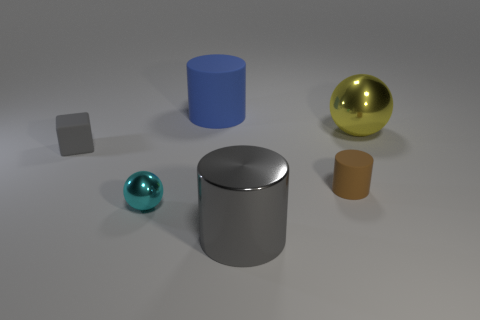What shape is the large shiny thing that is the same color as the tiny matte cube?
Your answer should be very brief. Cylinder. What number of objects are matte objects behind the small brown cylinder or gray metal cylinders that are in front of the large yellow shiny sphere?
Your answer should be very brief. 3. What is the shape of the tiny object that is the same material as the brown cylinder?
Your response must be concise. Cube. Is there anything else of the same color as the large matte thing?
Your response must be concise. No. There is another large thing that is the same shape as the blue matte thing; what is it made of?
Keep it short and to the point. Metal. What number of other things are the same size as the blue matte cylinder?
Your answer should be compact. 2. What material is the big blue cylinder?
Make the answer very short. Rubber. Is the number of tiny gray rubber things in front of the gray matte cube greater than the number of blue rubber objects?
Provide a succinct answer. No. Are any gray blocks visible?
Make the answer very short. Yes. What number of other objects are the same shape as the small gray rubber thing?
Your response must be concise. 0. 